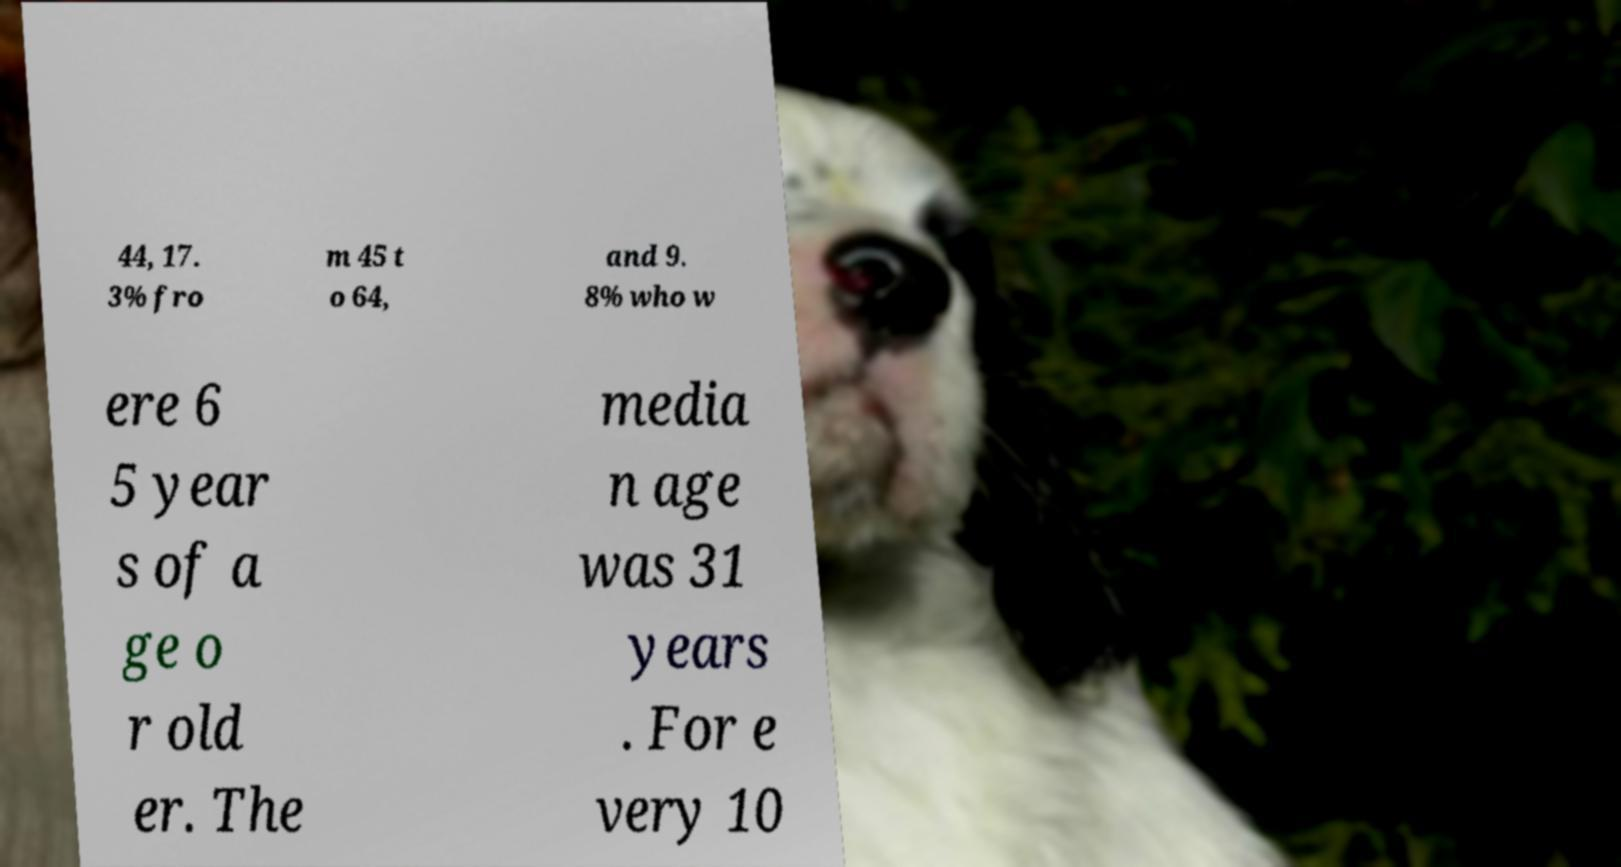I need the written content from this picture converted into text. Can you do that? 44, 17. 3% fro m 45 t o 64, and 9. 8% who w ere 6 5 year s of a ge o r old er. The media n age was 31 years . For e very 10 